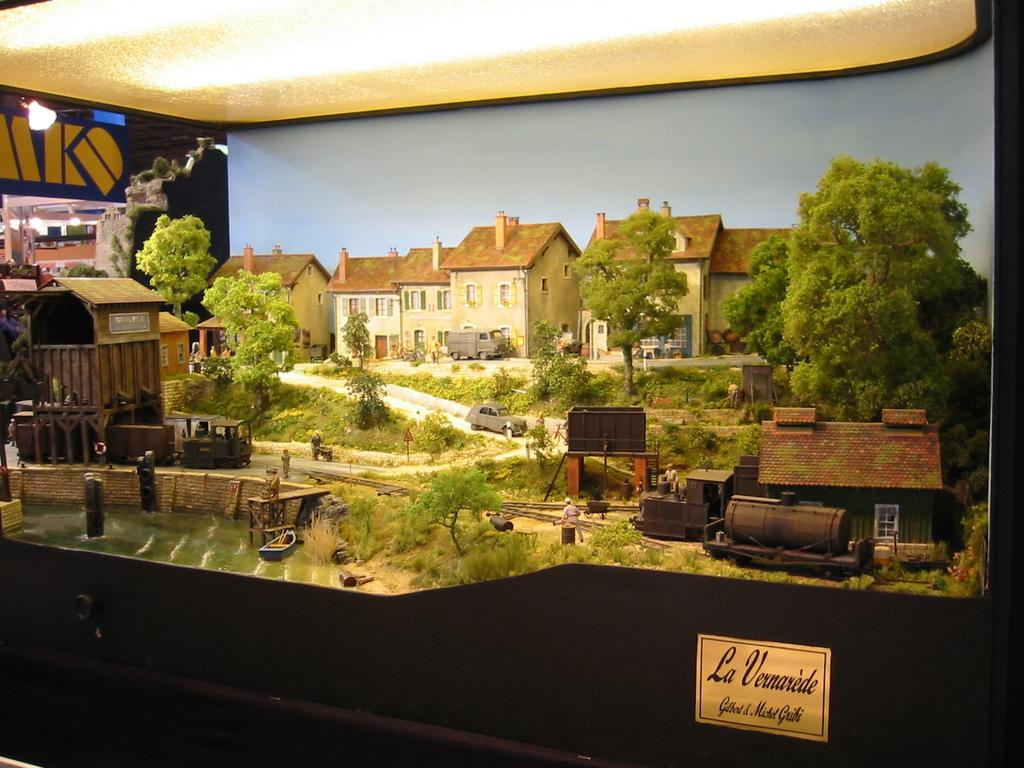Provide a one-sentence caption for the provided image. A scene of a town is on display and has a placard that reads,"La Vernarede.". 